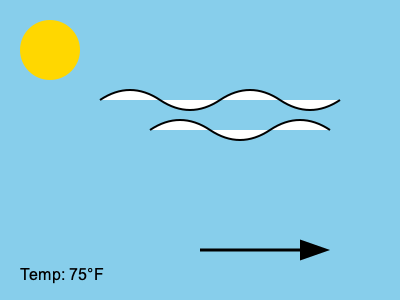As a skilled hunter, you're planning a crucial hunting trip. Based on the cloud formations, wind direction, and temperature shown in the image, what weather pattern can you predict for the next 6-12 hours, and how might this affect your hunting strategy? 1. Cloud formations: The image shows high, wispy clouds (cirrus clouds) which typically indicate fair weather but can also signal an approaching warm front.

2. Wind direction: The arrow shows wind moving from left to right (west to east), which often brings stable weather conditions in many regions.

3. Temperature: The temperature is 75°F (23.9°C), which is relatively warm and comfortable for outdoor activities.

4. Cirrus clouds moving in from the west, combined with warm temperatures, often precede a warm front.

5. A warm front typically brings:
   a) Gradually increasing cloud cover
   b) Rising temperatures
   c) Possibility of light precipitation in 6-12 hours

6. Hunting strategy implications:
   a) Game animals may become more active as the barometric pressure drops before the warm front.
   b) Scent dispersion may improve with increasing moisture in the air.
   c) Wind direction stability can help with scent control and stalking.
   d) Prepare for potential light rain in the later hours of the hunt.

7. As a hunter who sees Carl as a liability, you might:
   a) Plan a solo hunt to take advantage of the optimal conditions.
   b) Position yourself upwind of Carl to avoid his scent alerting game.
   c) Challenge Carl's weather interpretation if it differs from yours.
Answer: Approaching warm front; increased animal activity, stable wind for scent control, possible light rain later. 